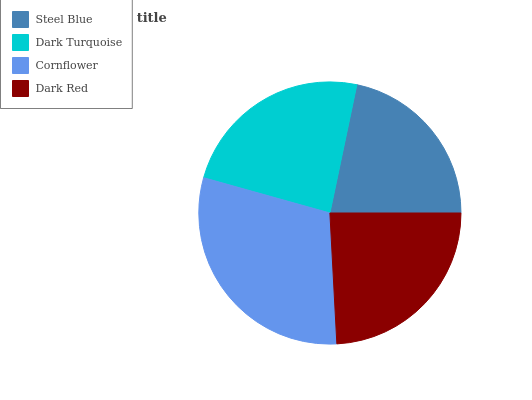Is Steel Blue the minimum?
Answer yes or no. Yes. Is Cornflower the maximum?
Answer yes or no. Yes. Is Dark Turquoise the minimum?
Answer yes or no. No. Is Dark Turquoise the maximum?
Answer yes or no. No. Is Dark Turquoise greater than Steel Blue?
Answer yes or no. Yes. Is Steel Blue less than Dark Turquoise?
Answer yes or no. Yes. Is Steel Blue greater than Dark Turquoise?
Answer yes or no. No. Is Dark Turquoise less than Steel Blue?
Answer yes or no. No. Is Dark Red the high median?
Answer yes or no. Yes. Is Dark Turquoise the low median?
Answer yes or no. Yes. Is Cornflower the high median?
Answer yes or no. No. Is Cornflower the low median?
Answer yes or no. No. 